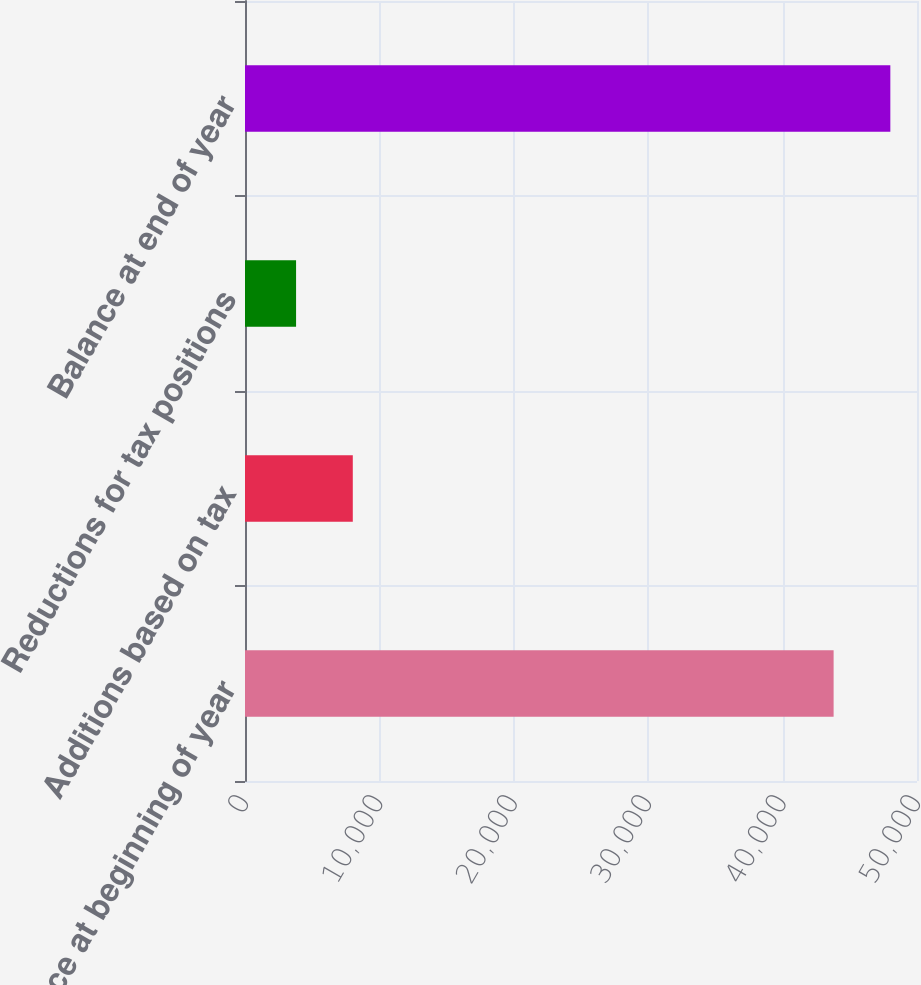Convert chart. <chart><loc_0><loc_0><loc_500><loc_500><bar_chart><fcel>Balance at beginning of year<fcel>Additions based on tax<fcel>Reductions for tax positions<fcel>Balance at end of year<nl><fcel>43796<fcel>8020.4<fcel>3800<fcel>48016.4<nl></chart> 